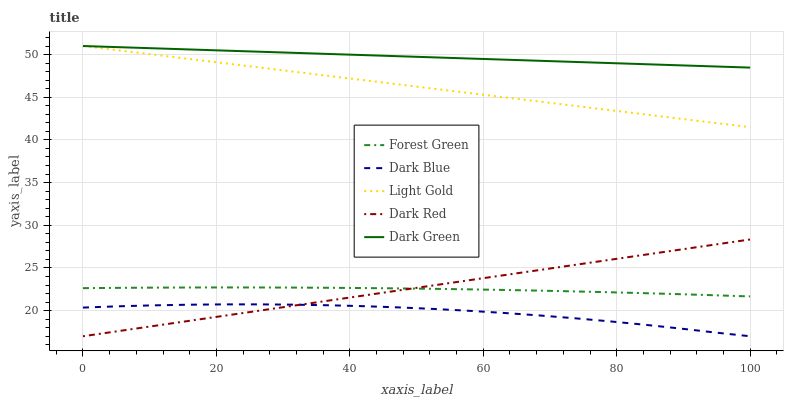Does Dark Blue have the minimum area under the curve?
Answer yes or no. Yes. Does Dark Green have the maximum area under the curve?
Answer yes or no. Yes. Does Forest Green have the minimum area under the curve?
Answer yes or no. No. Does Forest Green have the maximum area under the curve?
Answer yes or no. No. Is Dark Red the smoothest?
Answer yes or no. Yes. Is Dark Blue the roughest?
Answer yes or no. Yes. Is Forest Green the smoothest?
Answer yes or no. No. Is Forest Green the roughest?
Answer yes or no. No. Does Dark Blue have the lowest value?
Answer yes or no. Yes. Does Forest Green have the lowest value?
Answer yes or no. No. Does Light Gold have the highest value?
Answer yes or no. Yes. Does Forest Green have the highest value?
Answer yes or no. No. Is Dark Blue less than Forest Green?
Answer yes or no. Yes. Is Light Gold greater than Dark Blue?
Answer yes or no. Yes. Does Dark Red intersect Forest Green?
Answer yes or no. Yes. Is Dark Red less than Forest Green?
Answer yes or no. No. Is Dark Red greater than Forest Green?
Answer yes or no. No. Does Dark Blue intersect Forest Green?
Answer yes or no. No. 